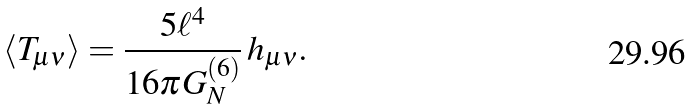Convert formula to latex. <formula><loc_0><loc_0><loc_500><loc_500>\langle T _ { \mu \nu } \rangle = \frac { 5 \ell ^ { 4 } } { 1 6 \pi G _ { N } ^ { ( 6 ) } } \, h _ { \mu \nu } .</formula> 